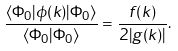Convert formula to latex. <formula><loc_0><loc_0><loc_500><loc_500>\frac { \langle \Phi _ { 0 } | \phi ( k ) | \Phi _ { 0 } \rangle } { \langle \Phi _ { 0 } | \Phi _ { 0 } \rangle } = \frac { f ( k ) } { 2 | g ( k ) | } .</formula> 